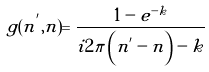Convert formula to latex. <formula><loc_0><loc_0><loc_500><loc_500>g ( n ^ { ^ { \prime } } , n ) = \frac { 1 - e ^ { - k } } { i 2 \pi \left ( n ^ { ^ { \prime } } - n \right ) - k }</formula> 